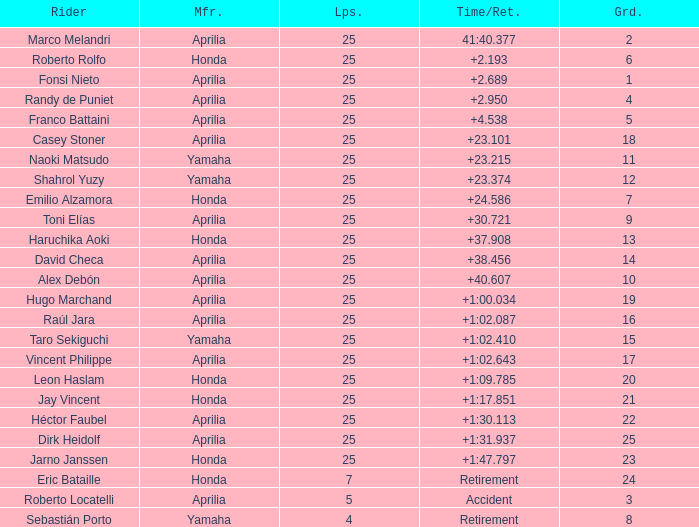Which Laps have a Time/Retired of +23.215, and a Grid larger than 11? None. 